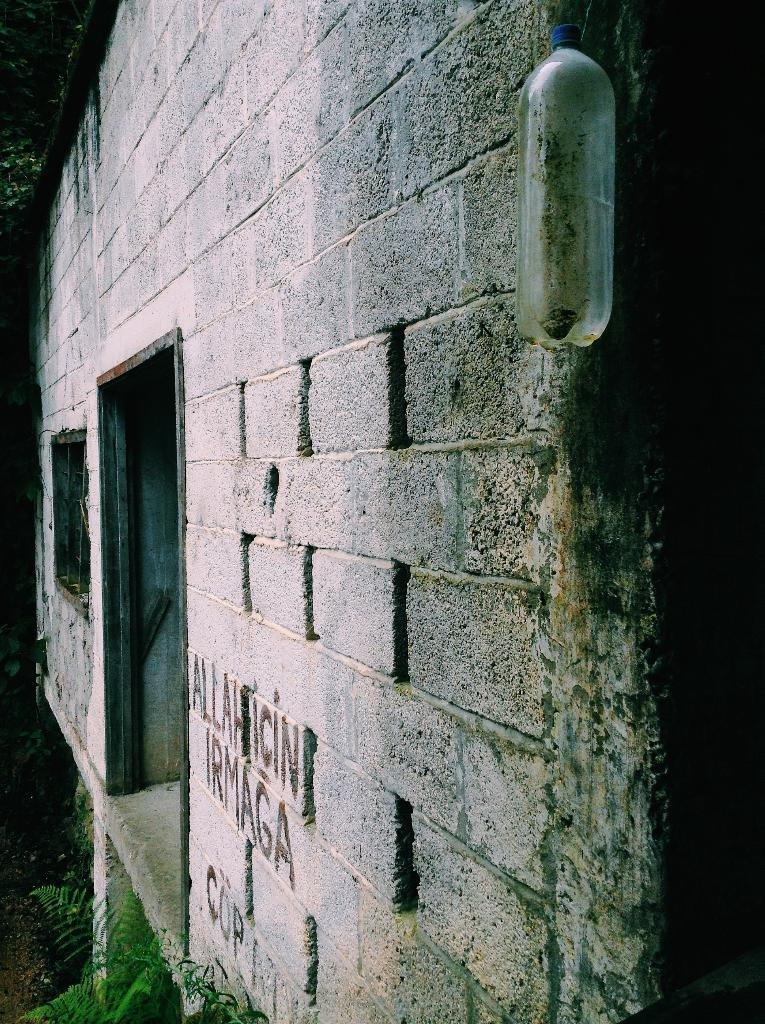Where was the image taken? The image was taken outdoors. What can be seen at the bottom of the image? There is a plant at the bottom of the image. What architectural feature is present in the middle of the image? There is a wall with a window in the middle of the image. What object can be seen in the image besides the plant and wall? There is a bottle in the image. What is the opinion of the ink on the wall in the image? There is no ink present on the wall in the image, so it is not possible to determine its opinion. 